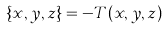<formula> <loc_0><loc_0><loc_500><loc_500>\{ x , y , z \} = - T ( x , y , z )</formula> 